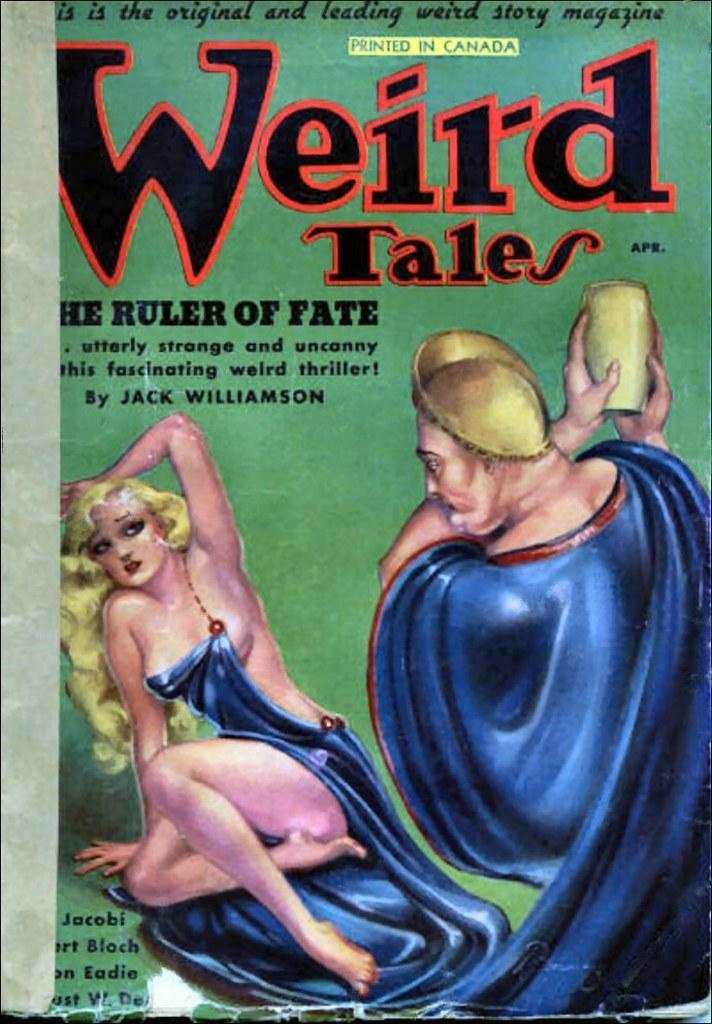How would you summarize this image in a sentence or two? In this picture I can observe a poster. I can observe text in the poster. The background is in green color. 